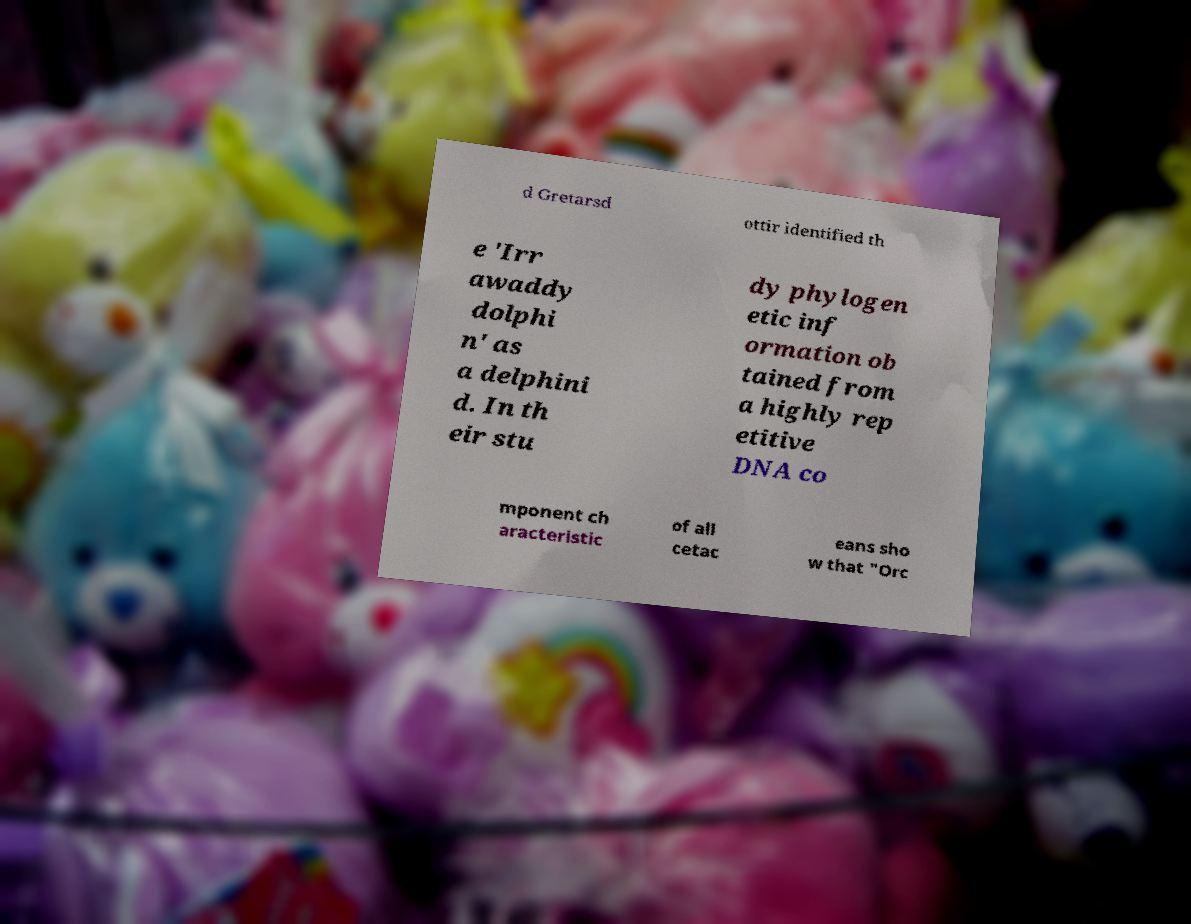What messages or text are displayed in this image? I need them in a readable, typed format. d Gretarsd ottir identified th e 'Irr awaddy dolphi n' as a delphini d. In th eir stu dy phylogen etic inf ormation ob tained from a highly rep etitive DNA co mponent ch aracteristic of all cetac eans sho w that "Orc 